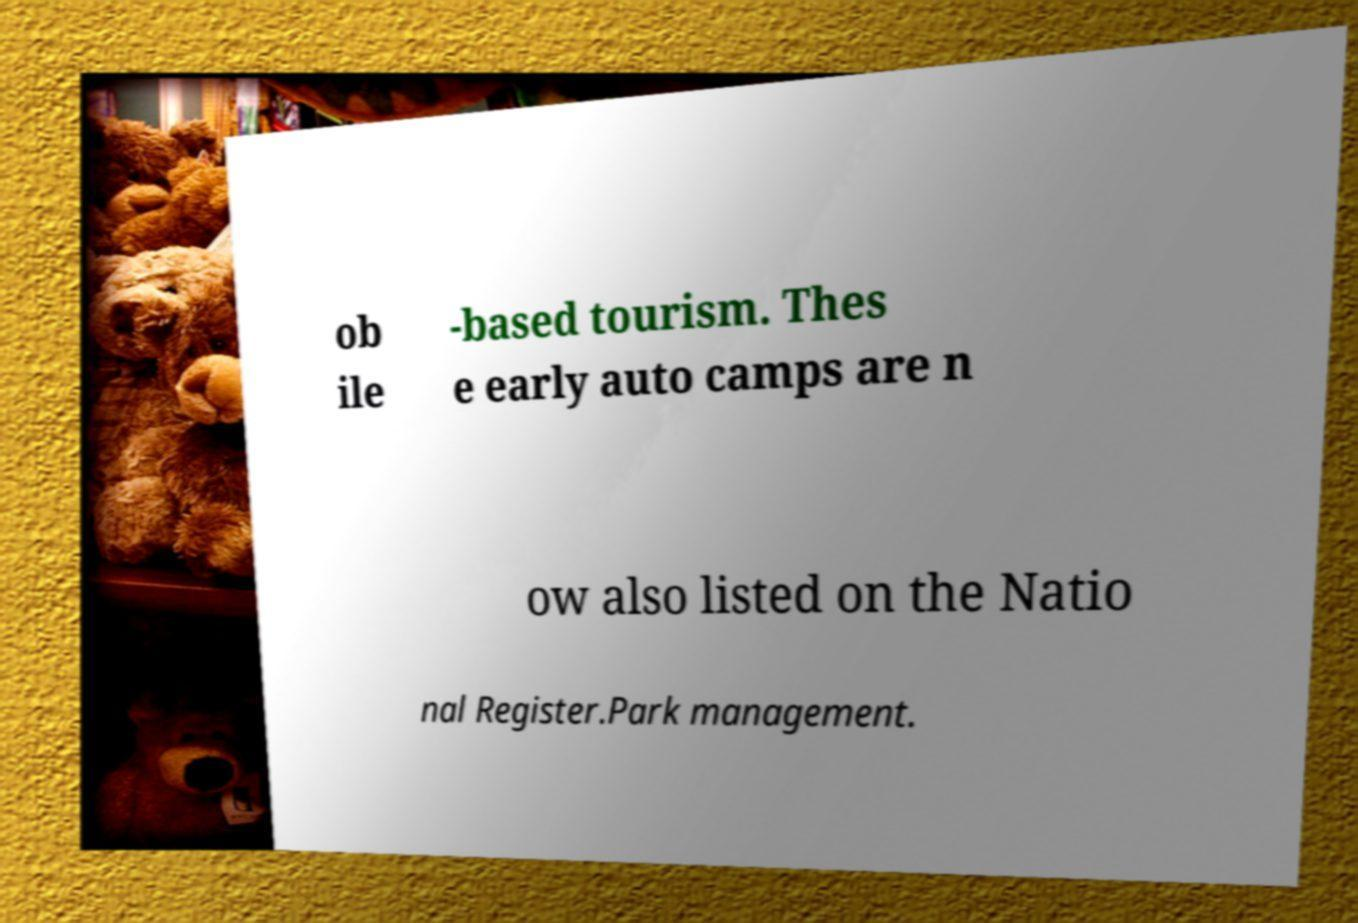Please read and relay the text visible in this image. What does it say? ob ile -based tourism. Thes e early auto camps are n ow also listed on the Natio nal Register.Park management. 